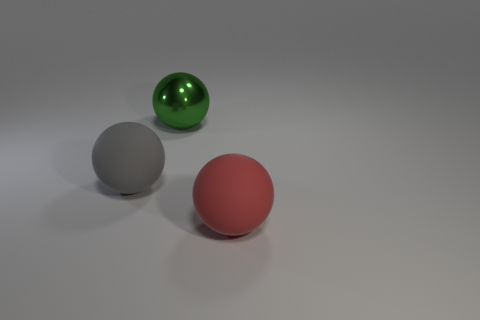Add 3 cyan cylinders. How many objects exist? 6 Subtract 0 blue blocks. How many objects are left? 3 Subtract all green matte things. Subtract all large balls. How many objects are left? 0 Add 2 red rubber spheres. How many red rubber spheres are left? 3 Add 1 gray metal objects. How many gray metal objects exist? 1 